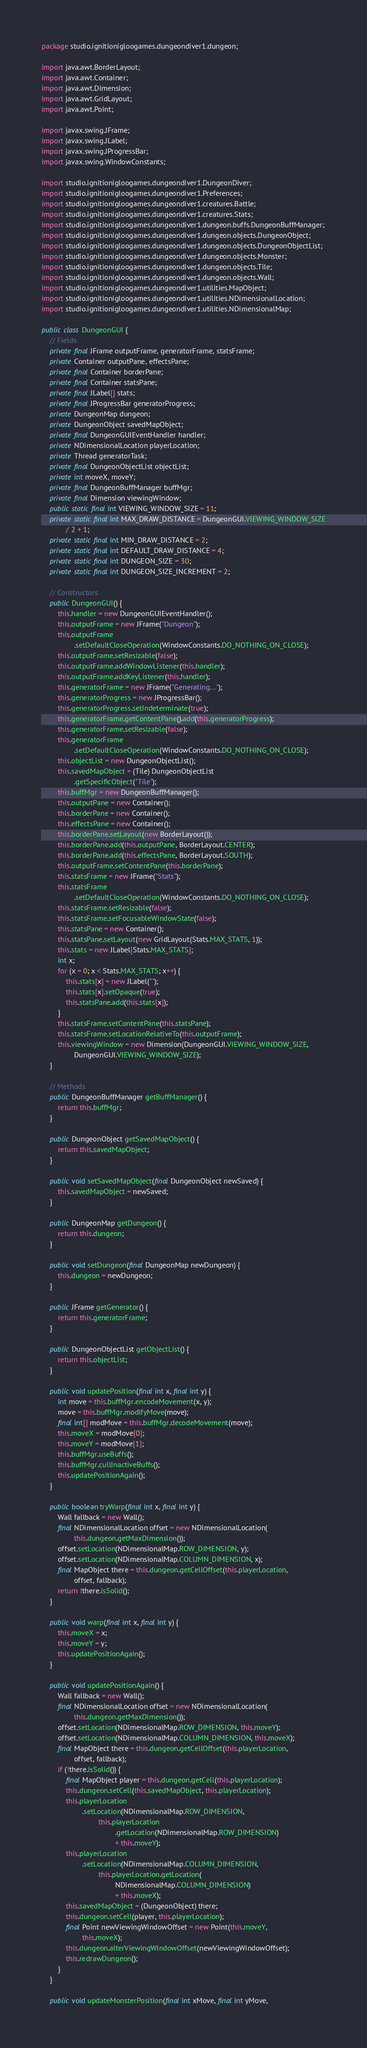Convert code to text. <code><loc_0><loc_0><loc_500><loc_500><_Java_>package studio.ignitionigloogames.dungeondiver1.dungeon;

import java.awt.BorderLayout;
import java.awt.Container;
import java.awt.Dimension;
import java.awt.GridLayout;
import java.awt.Point;

import javax.swing.JFrame;
import javax.swing.JLabel;
import javax.swing.JProgressBar;
import javax.swing.WindowConstants;

import studio.ignitionigloogames.dungeondiver1.DungeonDiver;
import studio.ignitionigloogames.dungeondiver1.Preferences;
import studio.ignitionigloogames.dungeondiver1.creatures.Battle;
import studio.ignitionigloogames.dungeondiver1.creatures.Stats;
import studio.ignitionigloogames.dungeondiver1.dungeon.buffs.DungeonBuffManager;
import studio.ignitionigloogames.dungeondiver1.dungeon.objects.DungeonObject;
import studio.ignitionigloogames.dungeondiver1.dungeon.objects.DungeonObjectList;
import studio.ignitionigloogames.dungeondiver1.dungeon.objects.Monster;
import studio.ignitionigloogames.dungeondiver1.dungeon.objects.Tile;
import studio.ignitionigloogames.dungeondiver1.dungeon.objects.Wall;
import studio.ignitionigloogames.dungeondiver1.utilities.MapObject;
import studio.ignitionigloogames.dungeondiver1.utilities.NDimensionalLocation;
import studio.ignitionigloogames.dungeondiver1.utilities.NDimensionalMap;

public class DungeonGUI {
    // Fields
    private final JFrame outputFrame, generatorFrame, statsFrame;
    private Container outputPane, effectsPane;
    private final Container borderPane;
    private final Container statsPane;
    private final JLabel[] stats;
    private final JProgressBar generatorProgress;
    private DungeonMap dungeon;
    private DungeonObject savedMapObject;
    private final DungeonGUIEventHandler handler;
    private NDimensionalLocation playerLocation;
    private Thread generatorTask;
    private final DungeonObjectList objectList;
    private int moveX, moveY;
    private final DungeonBuffManager buffMgr;
    private final Dimension viewingWindow;
    public static final int VIEWING_WINDOW_SIZE = 11;
    private static final int MAX_DRAW_DISTANCE = DungeonGUI.VIEWING_WINDOW_SIZE
            / 2 + 1;
    private static final int MIN_DRAW_DISTANCE = 2;
    private static final int DEFAULT_DRAW_DISTANCE = 4;
    private static final int DUNGEON_SIZE = 30;
    private static final int DUNGEON_SIZE_INCREMENT = 2;

    // Constructors
    public DungeonGUI() {
        this.handler = new DungeonGUIEventHandler();
        this.outputFrame = new JFrame("Dungeon");
        this.outputFrame
                .setDefaultCloseOperation(WindowConstants.DO_NOTHING_ON_CLOSE);
        this.outputFrame.setResizable(false);
        this.outputFrame.addWindowListener(this.handler);
        this.outputFrame.addKeyListener(this.handler);
        this.generatorFrame = new JFrame("Generating...");
        this.generatorProgress = new JProgressBar();
        this.generatorProgress.setIndeterminate(true);
        this.generatorFrame.getContentPane().add(this.generatorProgress);
        this.generatorFrame.setResizable(false);
        this.generatorFrame
                .setDefaultCloseOperation(WindowConstants.DO_NOTHING_ON_CLOSE);
        this.objectList = new DungeonObjectList();
        this.savedMapObject = (Tile) DungeonObjectList
                .getSpecificObject("Tile");
        this.buffMgr = new DungeonBuffManager();
        this.outputPane = new Container();
        this.borderPane = new Container();
        this.effectsPane = new Container();
        this.borderPane.setLayout(new BorderLayout());
        this.borderPane.add(this.outputPane, BorderLayout.CENTER);
        this.borderPane.add(this.effectsPane, BorderLayout.SOUTH);
        this.outputFrame.setContentPane(this.borderPane);
        this.statsFrame = new JFrame("Stats");
        this.statsFrame
                .setDefaultCloseOperation(WindowConstants.DO_NOTHING_ON_CLOSE);
        this.statsFrame.setResizable(false);
        this.statsFrame.setFocusableWindowState(false);
        this.statsPane = new Container();
        this.statsPane.setLayout(new GridLayout(Stats.MAX_STATS, 1));
        this.stats = new JLabel[Stats.MAX_STATS];
        int x;
        for (x = 0; x < Stats.MAX_STATS; x++) {
            this.stats[x] = new JLabel("");
            this.stats[x].setOpaque(true);
            this.statsPane.add(this.stats[x]);
        }
        this.statsFrame.setContentPane(this.statsPane);
        this.statsFrame.setLocationRelativeTo(this.outputFrame);
        this.viewingWindow = new Dimension(DungeonGUI.VIEWING_WINDOW_SIZE,
                DungeonGUI.VIEWING_WINDOW_SIZE);
    }

    // Methods
    public DungeonBuffManager getBuffManager() {
        return this.buffMgr;
    }

    public DungeonObject getSavedMapObject() {
        return this.savedMapObject;
    }

    public void setSavedMapObject(final DungeonObject newSaved) {
        this.savedMapObject = newSaved;
    }

    public DungeonMap getDungeon() {
        return this.dungeon;
    }

    public void setDungeon(final DungeonMap newDungeon) {
        this.dungeon = newDungeon;
    }

    public JFrame getGenerator() {
        return this.generatorFrame;
    }

    public DungeonObjectList getObjectList() {
        return this.objectList;
    }

    public void updatePosition(final int x, final int y) {
        int move = this.buffMgr.encodeMovement(x, y);
        move = this.buffMgr.modifyMove(move);
        final int[] modMove = this.buffMgr.decodeMovement(move);
        this.moveX = modMove[0];
        this.moveY = modMove[1];
        this.buffMgr.useBuffs();
        this.buffMgr.cullInactiveBuffs();
        this.updatePositionAgain();
    }

    public boolean tryWarp(final int x, final int y) {
        Wall fallback = new Wall();
        final NDimensionalLocation offset = new NDimensionalLocation(
                this.dungeon.getMaxDimension());
        offset.setLocation(NDimensionalMap.ROW_DIMENSION, y);
        offset.setLocation(NDimensionalMap.COLUMN_DIMENSION, x);
        final MapObject there = this.dungeon.getCellOffset(this.playerLocation,
                offset, fallback);
        return !there.isSolid();
    }

    public void warp(final int x, final int y) {
        this.moveX = x;
        this.moveY = y;
        this.updatePositionAgain();
    }

    public void updatePositionAgain() {
        Wall fallback = new Wall();
        final NDimensionalLocation offset = new NDimensionalLocation(
                this.dungeon.getMaxDimension());
        offset.setLocation(NDimensionalMap.ROW_DIMENSION, this.moveY);
        offset.setLocation(NDimensionalMap.COLUMN_DIMENSION, this.moveX);
        final MapObject there = this.dungeon.getCellOffset(this.playerLocation,
                offset, fallback);
        if (!there.isSolid()) {
            final MapObject player = this.dungeon.getCell(this.playerLocation);
            this.dungeon.setCell(this.savedMapObject, this.playerLocation);
            this.playerLocation
                    .setLocation(NDimensionalMap.ROW_DIMENSION,
                            this.playerLocation
                                    .getLocation(NDimensionalMap.ROW_DIMENSION)
                                    + this.moveY);
            this.playerLocation
                    .setLocation(NDimensionalMap.COLUMN_DIMENSION,
                            this.playerLocation.getLocation(
                                    NDimensionalMap.COLUMN_DIMENSION)
                                    + this.moveX);
            this.savedMapObject = (DungeonObject) there;
            this.dungeon.setCell(player, this.playerLocation);
            final Point newViewingWindowOffset = new Point(this.moveY,
                    this.moveX);
            this.dungeon.alterViewingWindowOffset(newViewingWindowOffset);
            this.redrawDungeon();
        }
    }

    public void updateMonsterPosition(final int xMove, final int yMove,</code> 